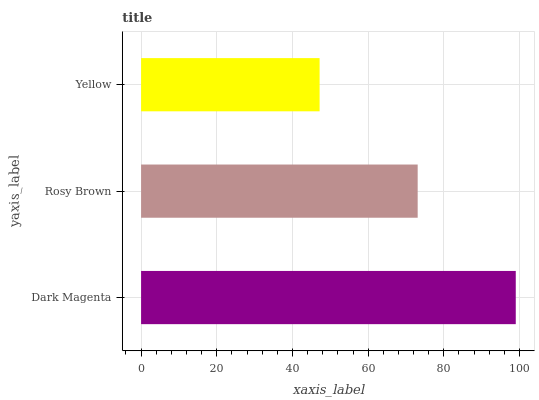Is Yellow the minimum?
Answer yes or no. Yes. Is Dark Magenta the maximum?
Answer yes or no. Yes. Is Rosy Brown the minimum?
Answer yes or no. No. Is Rosy Brown the maximum?
Answer yes or no. No. Is Dark Magenta greater than Rosy Brown?
Answer yes or no. Yes. Is Rosy Brown less than Dark Magenta?
Answer yes or no. Yes. Is Rosy Brown greater than Dark Magenta?
Answer yes or no. No. Is Dark Magenta less than Rosy Brown?
Answer yes or no. No. Is Rosy Brown the high median?
Answer yes or no. Yes. Is Rosy Brown the low median?
Answer yes or no. Yes. Is Yellow the high median?
Answer yes or no. No. Is Yellow the low median?
Answer yes or no. No. 